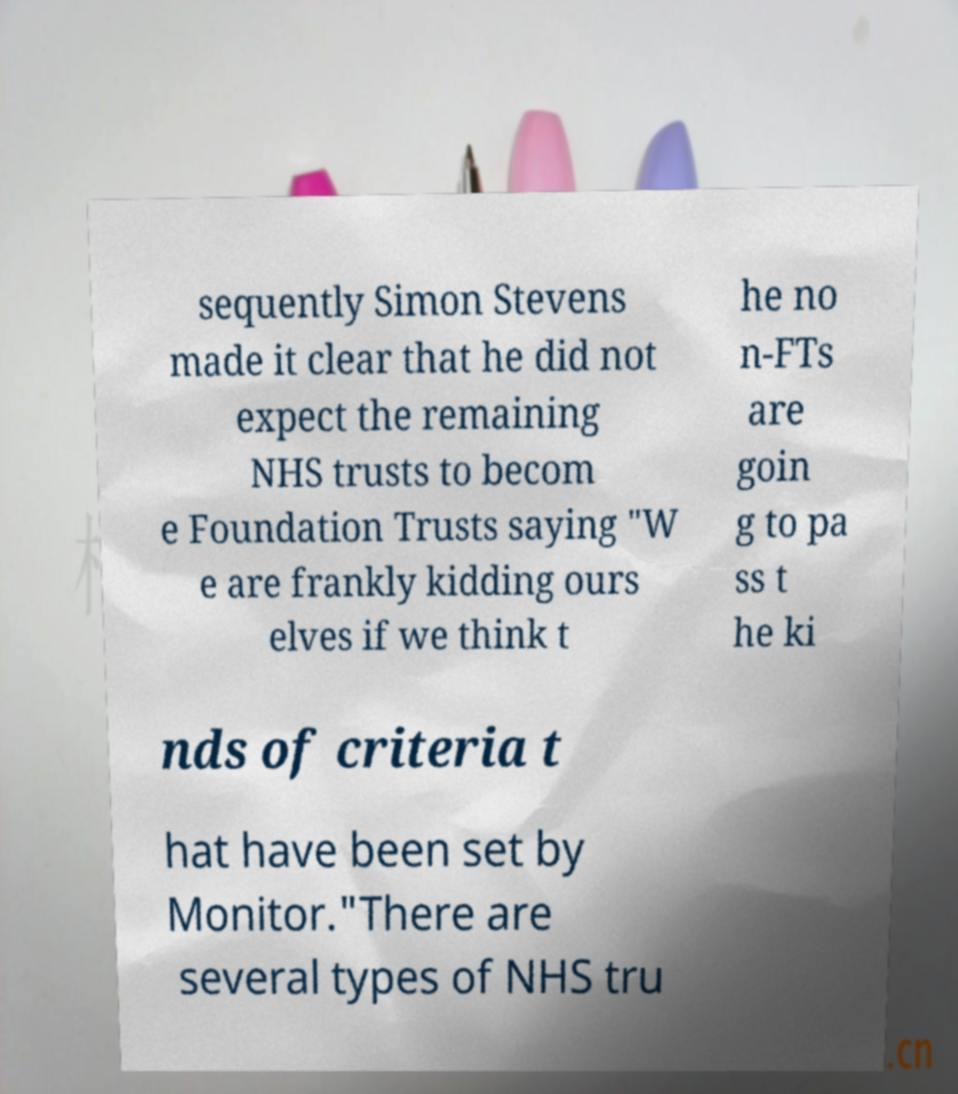I need the written content from this picture converted into text. Can you do that? sequently Simon Stevens made it clear that he did not expect the remaining NHS trusts to becom e Foundation Trusts saying "W e are frankly kidding ours elves if we think t he no n-FTs are goin g to pa ss t he ki nds of criteria t hat have been set by Monitor."There are several types of NHS tru 